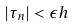<formula> <loc_0><loc_0><loc_500><loc_500>| \tau _ { n } | < \epsilon h</formula> 